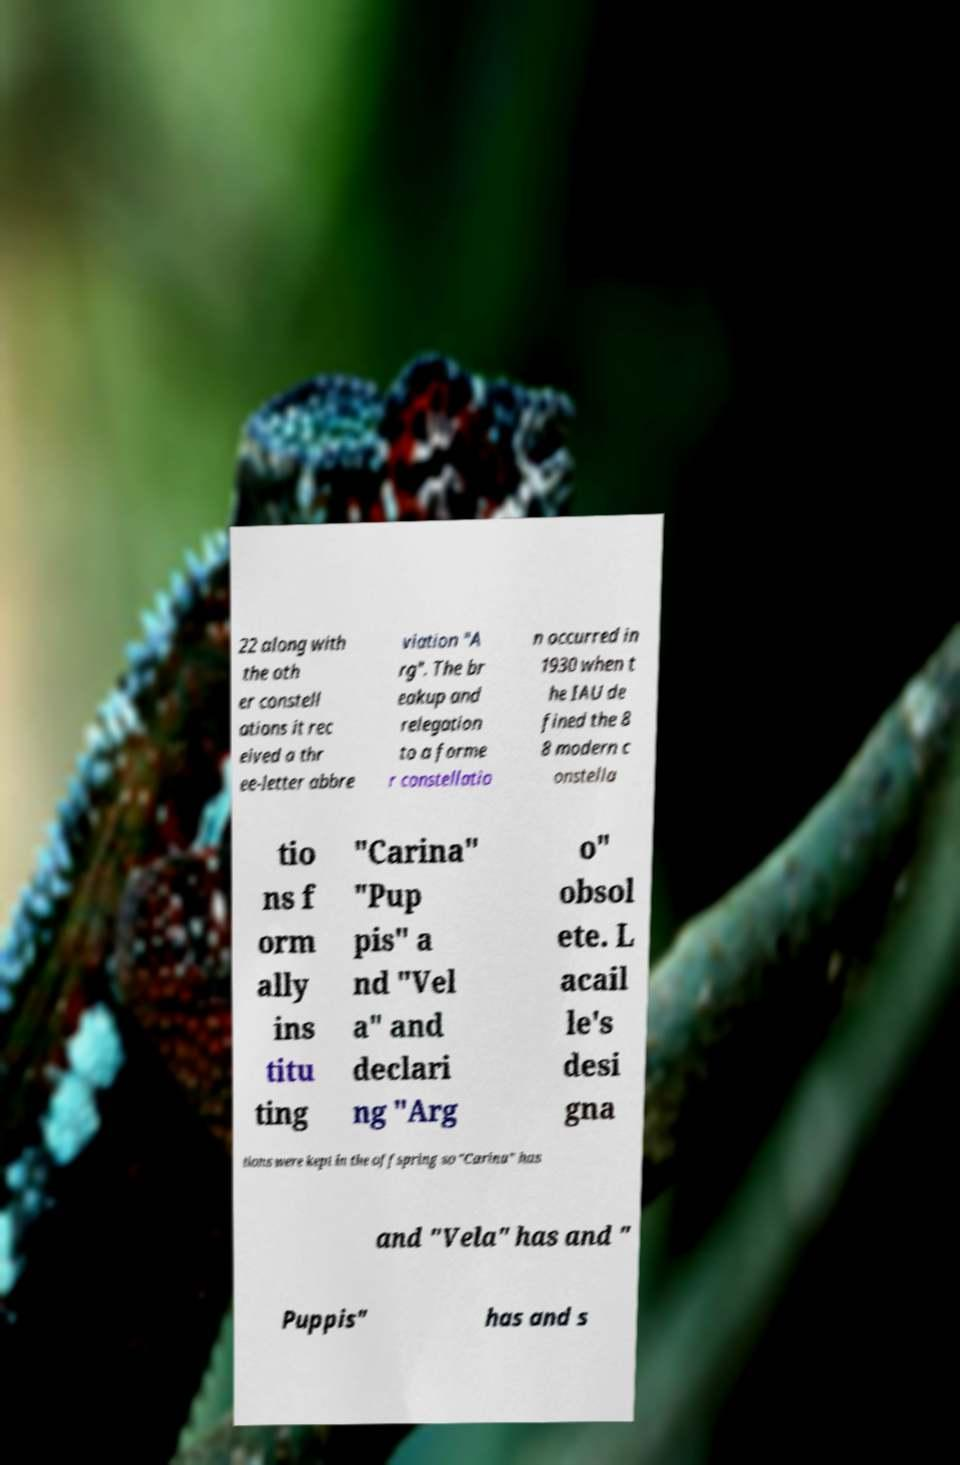What messages or text are displayed in this image? I need them in a readable, typed format. 22 along with the oth er constell ations it rec eived a thr ee-letter abbre viation "A rg". The br eakup and relegation to a forme r constellatio n occurred in 1930 when t he IAU de fined the 8 8 modern c onstella tio ns f orm ally ins titu ting "Carina" "Pup pis" a nd "Vel a" and declari ng "Arg o" obsol ete. L acail le's desi gna tions were kept in the offspring so "Carina" has and "Vela" has and " Puppis" has and s 